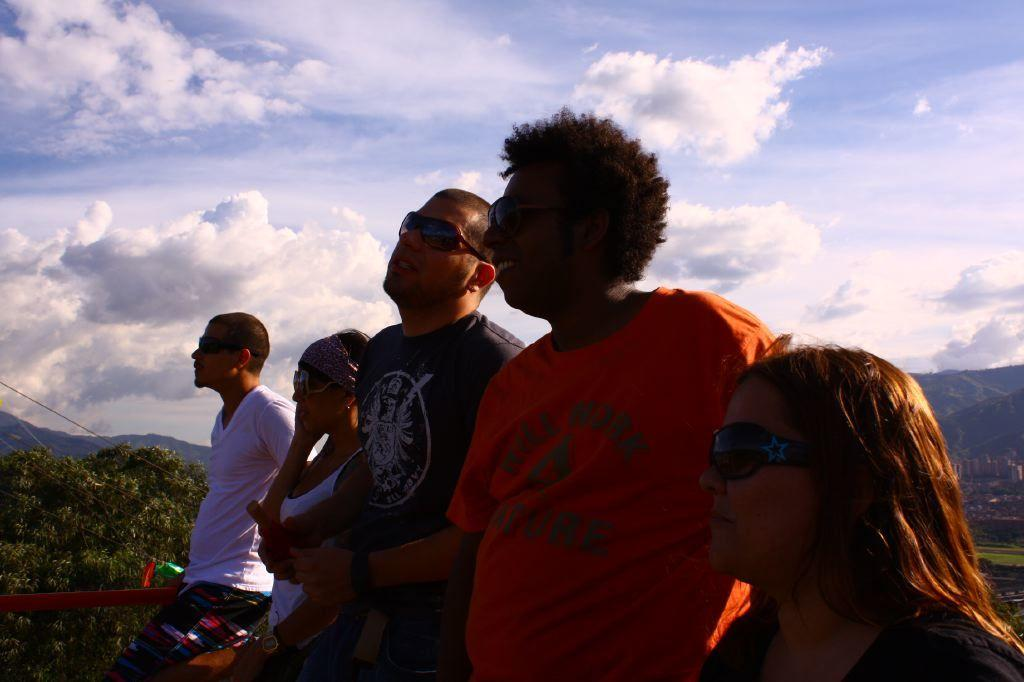How many people are in the image? There are five people in the image, three men and two women. What are the people in the image doing? The people are standing. What can be seen in the background of the image? There are trees and mountains in the background of the image. What is visible at the top of the image? The sky is visible at the top of the image. What type of clover is growing on the heads of the people in the image? There is no clover visible on the heads of the people in the image. How does the cork affect the movement of the people in the image? There is no cork present in the image, so it cannot affect the movement of the people. 